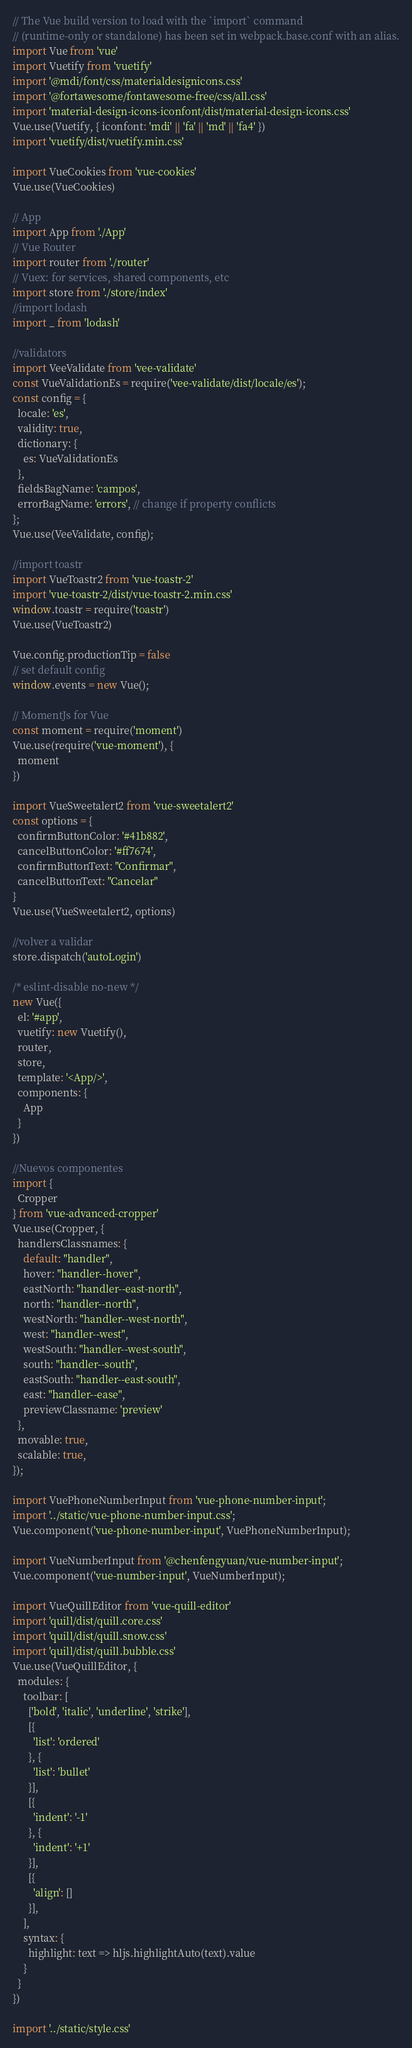Convert code to text. <code><loc_0><loc_0><loc_500><loc_500><_JavaScript_>// The Vue build version to load with the `import` command
// (runtime-only or standalone) has been set in webpack.base.conf with an alias.
import Vue from 'vue'
import Vuetify from 'vuetify'
import '@mdi/font/css/materialdesignicons.css'
import '@fortawesome/fontawesome-free/css/all.css'
import 'material-design-icons-iconfont/dist/material-design-icons.css'
Vue.use(Vuetify, { iconfont: 'mdi' || 'fa' || 'md' || 'fa4' })
import 'vuetify/dist/vuetify.min.css'

import VueCookies from 'vue-cookies'
Vue.use(VueCookies)

// App
import App from './App'
// Vue Router
import router from './router'
// Vuex: for services, shared components, etc
import store from './store/index'
//import lodash
import _ from 'lodash'

//validators
import VeeValidate from 'vee-validate'
const VueValidationEs = require('vee-validate/dist/locale/es');
const config = {
  locale: 'es',
  validity: true,
  dictionary: {
    es: VueValidationEs
  },
  fieldsBagName: 'campos',
  errorBagName: 'errors', // change if property conflicts
};
Vue.use(VeeValidate, config);

//import toastr
import VueToastr2 from 'vue-toastr-2'
import 'vue-toastr-2/dist/vue-toastr-2.min.css'
window.toastr = require('toastr')
Vue.use(VueToastr2)

Vue.config.productionTip = false
// set default config
window.events = new Vue();

// MomentJs for Vue
const moment = require('moment')
Vue.use(require('vue-moment'), {
  moment
})

import VueSweetalert2 from 'vue-sweetalert2'
const options = {
  confirmButtonColor: '#41b882',
  cancelButtonColor: '#ff7674',
  confirmButtonText: "Confirmar",
  cancelButtonText: "Cancelar"
}
Vue.use(VueSweetalert2, options)

//volver a validar
store.dispatch('autoLogin')

/* eslint-disable no-new */
new Vue({
  el: '#app',
  vuetify: new Vuetify(),
  router,
  store,
  template: '<App/>',
  components: {
    App
  }
})

//Nuevos componentes
import {
  Cropper
} from 'vue-advanced-cropper'
Vue.use(Cropper, {
  handlersClassnames: {
    default: "handler",
    hover: "handler--hover",
    eastNorth: "handler--east-north",
    north: "handler--north",
    westNorth: "handler--west-north",
    west: "handler--west",
    westSouth: "handler--west-south",
    south: "handler--south",
    eastSouth: "handler--east-south",
    east: "handler--ease",
    previewClassname: 'preview'
  },
  movable: true,
  scalable: true,
});

import VuePhoneNumberInput from 'vue-phone-number-input';
import '../static/vue-phone-number-input.css';
Vue.component('vue-phone-number-input', VuePhoneNumberInput);

import VueNumberInput from '@chenfengyuan/vue-number-input';
Vue.component('vue-number-input', VueNumberInput);

import VueQuillEditor from 'vue-quill-editor'
import 'quill/dist/quill.core.css'
import 'quill/dist/quill.snow.css'
import 'quill/dist/quill.bubble.css'
Vue.use(VueQuillEditor, {
  modules: {
    toolbar: [
      ['bold', 'italic', 'underline', 'strike'],
      [{
        'list': 'ordered'
      }, {
        'list': 'bullet'
      }],
      [{
        'indent': '-1'
      }, {
        'indent': '+1'
      }],
      [{
        'align': []
      }],
    ],
    syntax: {
      highlight: text => hljs.highlightAuto(text).value
    }
  }
})

import '../static/style.css'</code> 